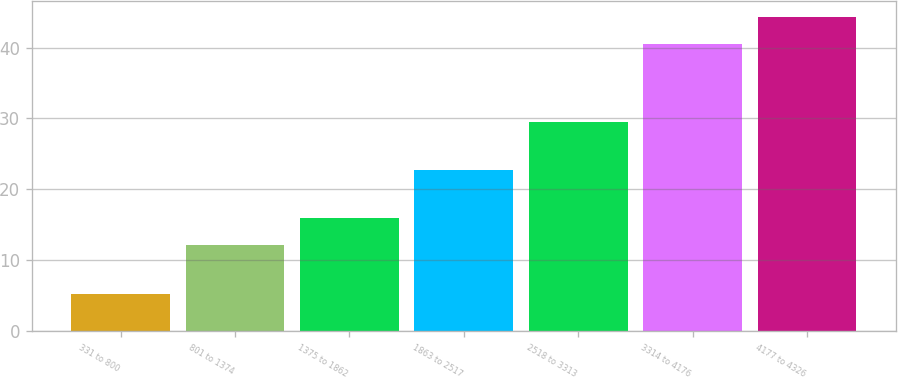Convert chart. <chart><loc_0><loc_0><loc_500><loc_500><bar_chart><fcel>331 to 800<fcel>801 to 1374<fcel>1375 to 1862<fcel>1863 to 2517<fcel>2518 to 3313<fcel>3314 to 4176<fcel>4177 to 4326<nl><fcel>5.26<fcel>12.13<fcel>15.92<fcel>22.73<fcel>29.49<fcel>40.54<fcel>44.33<nl></chart> 